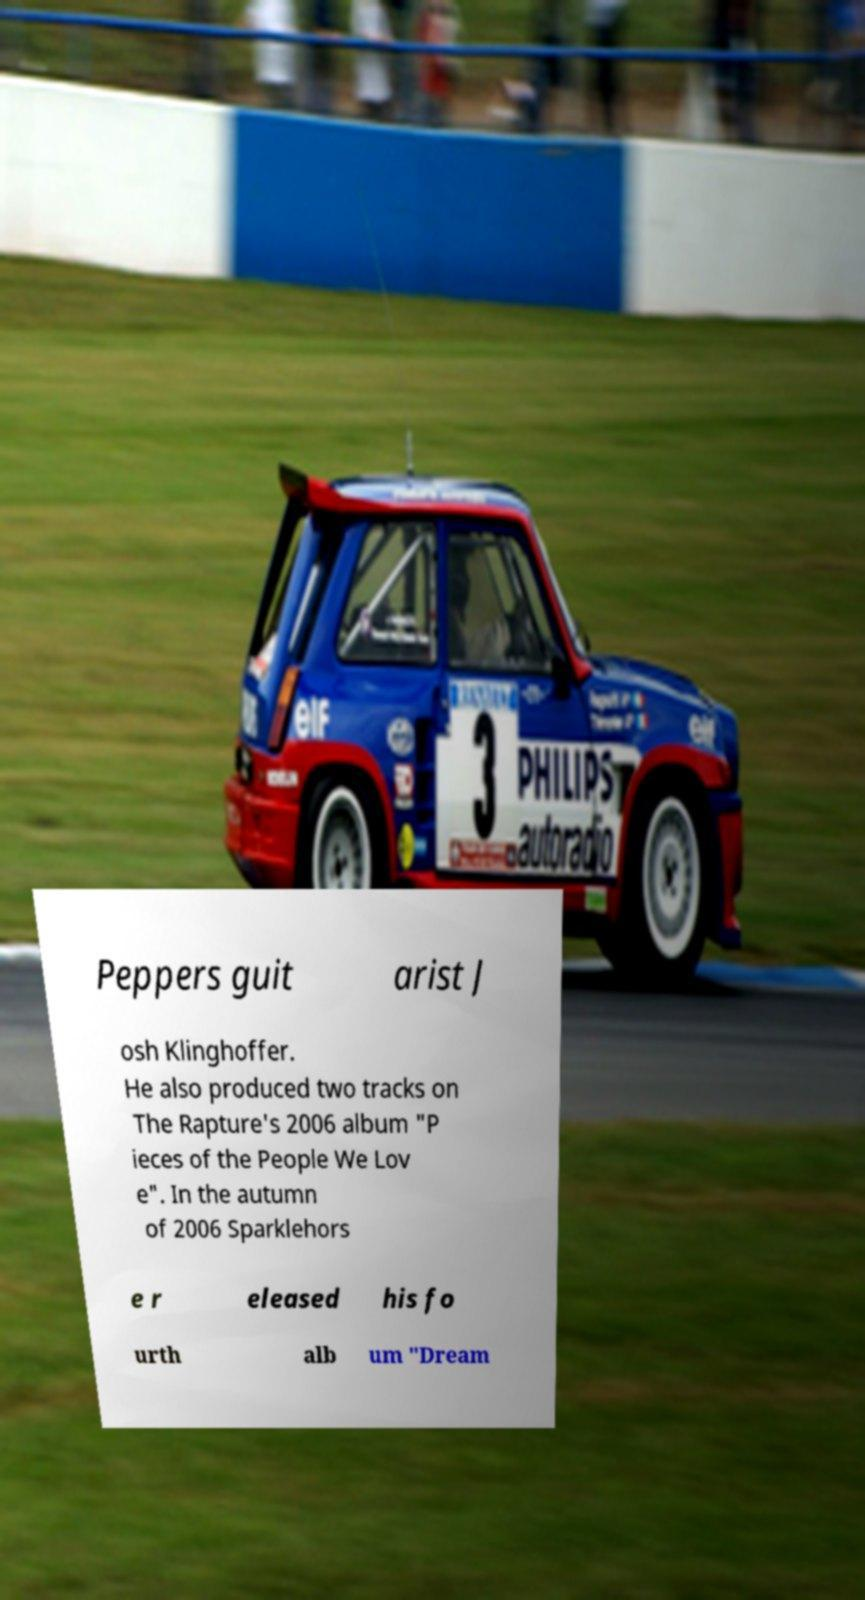Can you read and provide the text displayed in the image?This photo seems to have some interesting text. Can you extract and type it out for me? Peppers guit arist J osh Klinghoffer. He also produced two tracks on The Rapture's 2006 album "P ieces of the People We Lov e". In the autumn of 2006 Sparklehors e r eleased his fo urth alb um "Dream 